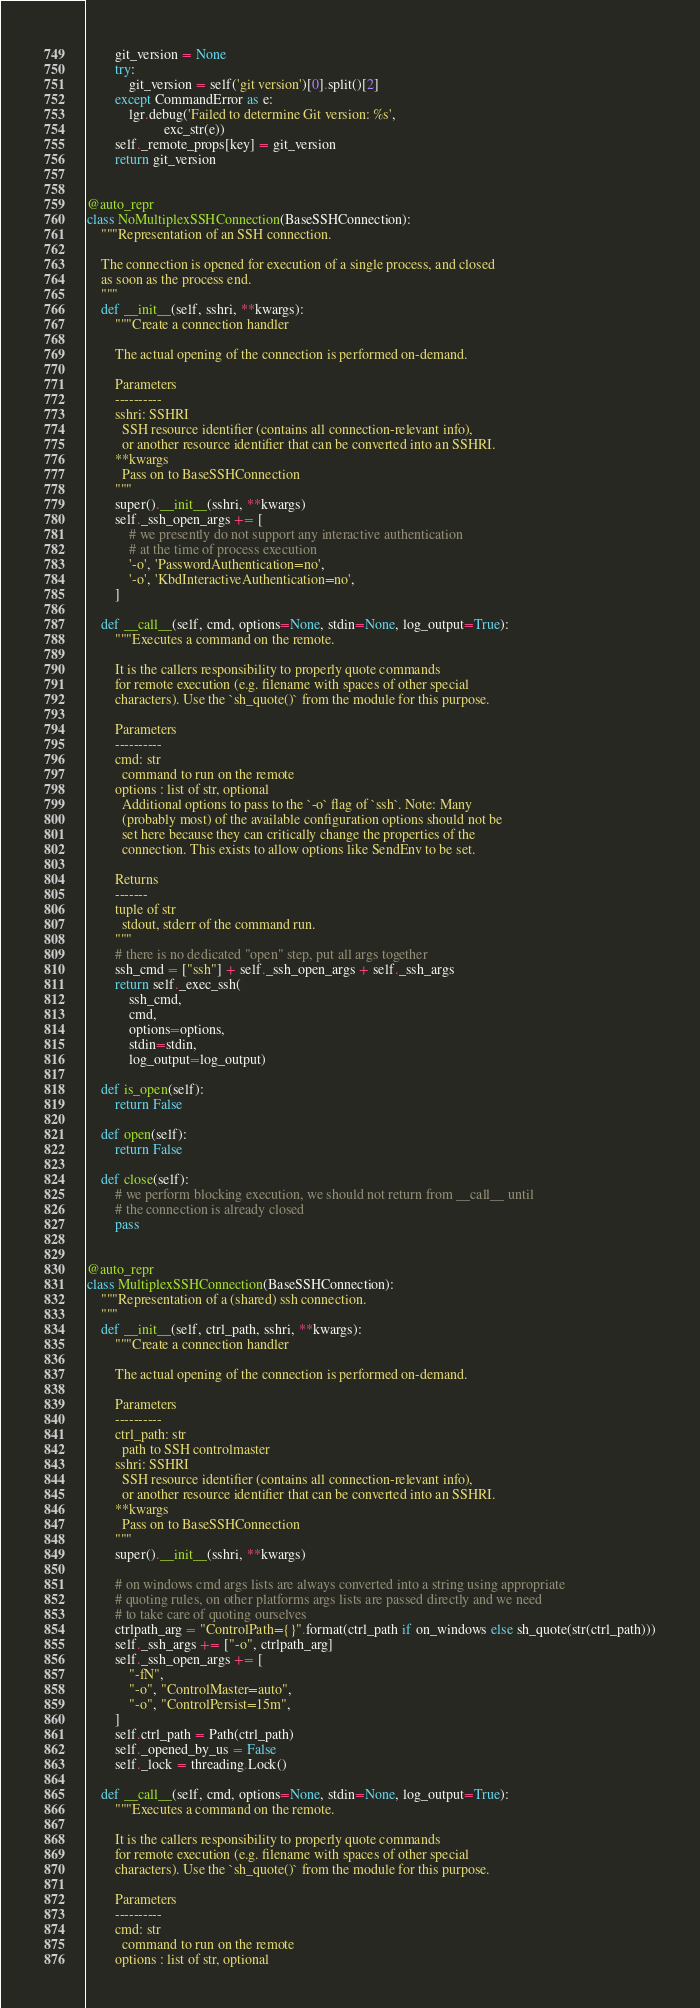Convert code to text. <code><loc_0><loc_0><loc_500><loc_500><_Python_>        git_version = None
        try:
            git_version = self('git version')[0].split()[2]
        except CommandError as e:
            lgr.debug('Failed to determine Git version: %s',
                      exc_str(e))
        self._remote_props[key] = git_version
        return git_version


@auto_repr
class NoMultiplexSSHConnection(BaseSSHConnection):
    """Representation of an SSH connection.

    The connection is opened for execution of a single process, and closed
    as soon as the process end.
    """
    def __init__(self, sshri, **kwargs):
        """Create a connection handler

        The actual opening of the connection is performed on-demand.

        Parameters
        ----------
        sshri: SSHRI
          SSH resource identifier (contains all connection-relevant info),
          or another resource identifier that can be converted into an SSHRI.
        **kwargs
          Pass on to BaseSSHConnection
        """
        super().__init__(sshri, **kwargs)
        self._ssh_open_args += [
            # we presently do not support any interactive authentication
            # at the time of process execution
            '-o', 'PasswordAuthentication=no',
            '-o', 'KbdInteractiveAuthentication=no',
        ]

    def __call__(self, cmd, options=None, stdin=None, log_output=True):
        """Executes a command on the remote.

        It is the callers responsibility to properly quote commands
        for remote execution (e.g. filename with spaces of other special
        characters). Use the `sh_quote()` from the module for this purpose.

        Parameters
        ----------
        cmd: str
          command to run on the remote
        options : list of str, optional
          Additional options to pass to the `-o` flag of `ssh`. Note: Many
          (probably most) of the available configuration options should not be
          set here because they can critically change the properties of the
          connection. This exists to allow options like SendEnv to be set.

        Returns
        -------
        tuple of str
          stdout, stderr of the command run.
        """
        # there is no dedicated "open" step, put all args together
        ssh_cmd = ["ssh"] + self._ssh_open_args + self._ssh_args
        return self._exec_ssh(
            ssh_cmd,
            cmd,
            options=options,
            stdin=stdin,
            log_output=log_output)

    def is_open(self):
        return False

    def open(self):
        return False

    def close(self):
        # we perform blocking execution, we should not return from __call__ until
        # the connection is already closed
        pass


@auto_repr
class MultiplexSSHConnection(BaseSSHConnection):
    """Representation of a (shared) ssh connection.
    """
    def __init__(self, ctrl_path, sshri, **kwargs):
        """Create a connection handler

        The actual opening of the connection is performed on-demand.

        Parameters
        ----------
        ctrl_path: str
          path to SSH controlmaster
        sshri: SSHRI
          SSH resource identifier (contains all connection-relevant info),
          or another resource identifier that can be converted into an SSHRI.
        **kwargs
          Pass on to BaseSSHConnection
        """
        super().__init__(sshri, **kwargs)

        # on windows cmd args lists are always converted into a string using appropriate
        # quoting rules, on other platforms args lists are passed directly and we need
        # to take care of quoting ourselves
        ctrlpath_arg = "ControlPath={}".format(ctrl_path if on_windows else sh_quote(str(ctrl_path)))
        self._ssh_args += ["-o", ctrlpath_arg]
        self._ssh_open_args += [
            "-fN",
            "-o", "ControlMaster=auto",
            "-o", "ControlPersist=15m",
        ]
        self.ctrl_path = Path(ctrl_path)
        self._opened_by_us = False
        self._lock = threading.Lock()

    def __call__(self, cmd, options=None, stdin=None, log_output=True):
        """Executes a command on the remote.

        It is the callers responsibility to properly quote commands
        for remote execution (e.g. filename with spaces of other special
        characters). Use the `sh_quote()` from the module for this purpose.

        Parameters
        ----------
        cmd: str
          command to run on the remote
        options : list of str, optional</code> 